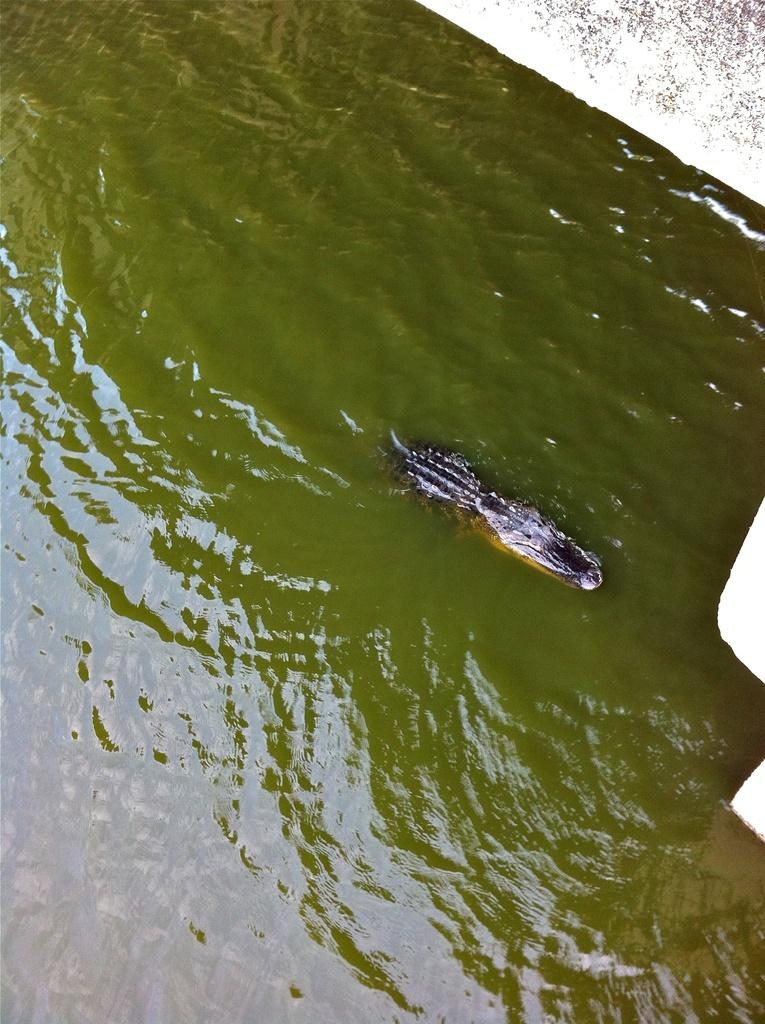What animal is in the water in the image? There is a crocodile in the water in the image. What structure can be seen in the image? There is a wall visible in the image. What type of home does the crocodile live in, as seen in the image? The image does not show the crocodile's home; it only shows the crocodile in the water and a wall in the background. What relation does the crocodile have with the wall in the image? The image does not show any relation between the crocodile and the wall; they are simply two separate elements in the scene. 